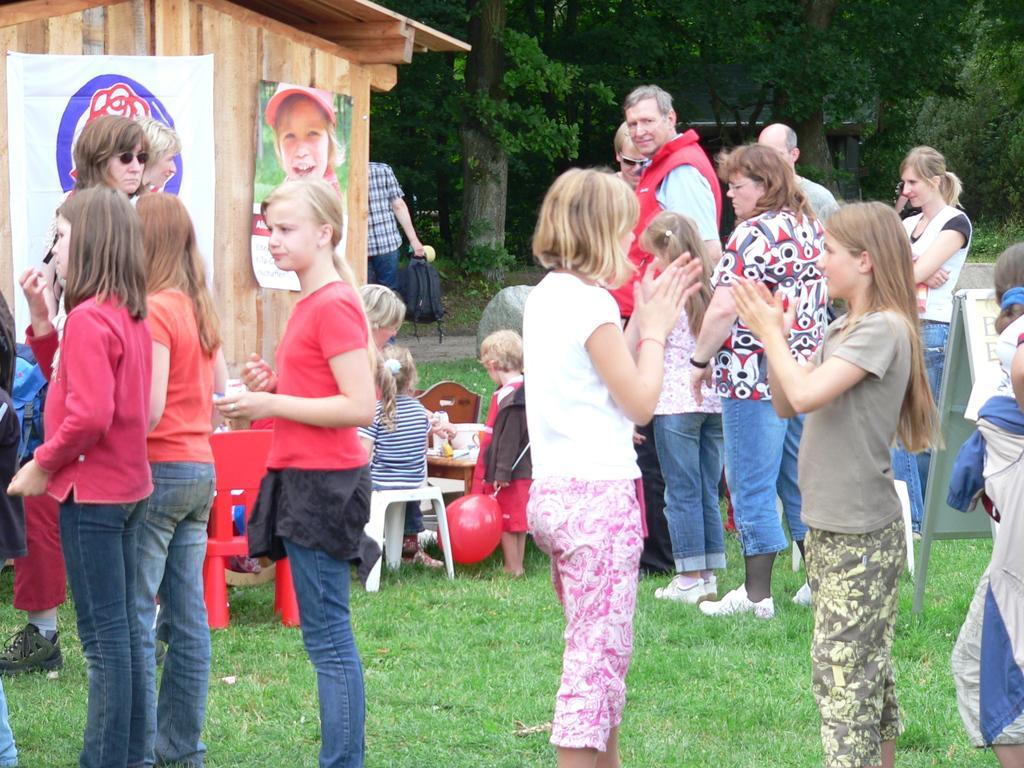Could you give a brief overview of what you see in this image? In this picture we can see a group of people standing on grass, chairs, balloon, banners on the wall and in the background we can see trees. 